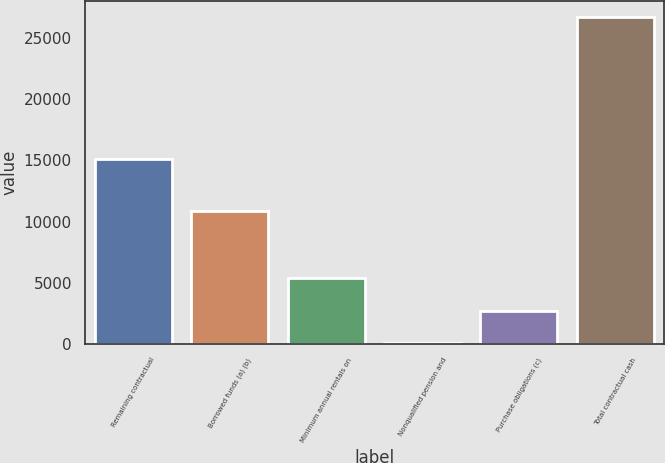<chart> <loc_0><loc_0><loc_500><loc_500><bar_chart><fcel>Remaining contractual<fcel>Borrowed funds (a) (b)<fcel>Minimum annual rentals on<fcel>Nonqualified pension and<fcel>Purchase obligations (c)<fcel>Total contractual cash<nl><fcel>15092<fcel>10863<fcel>5389.8<fcel>51<fcel>2720.4<fcel>26745<nl></chart> 